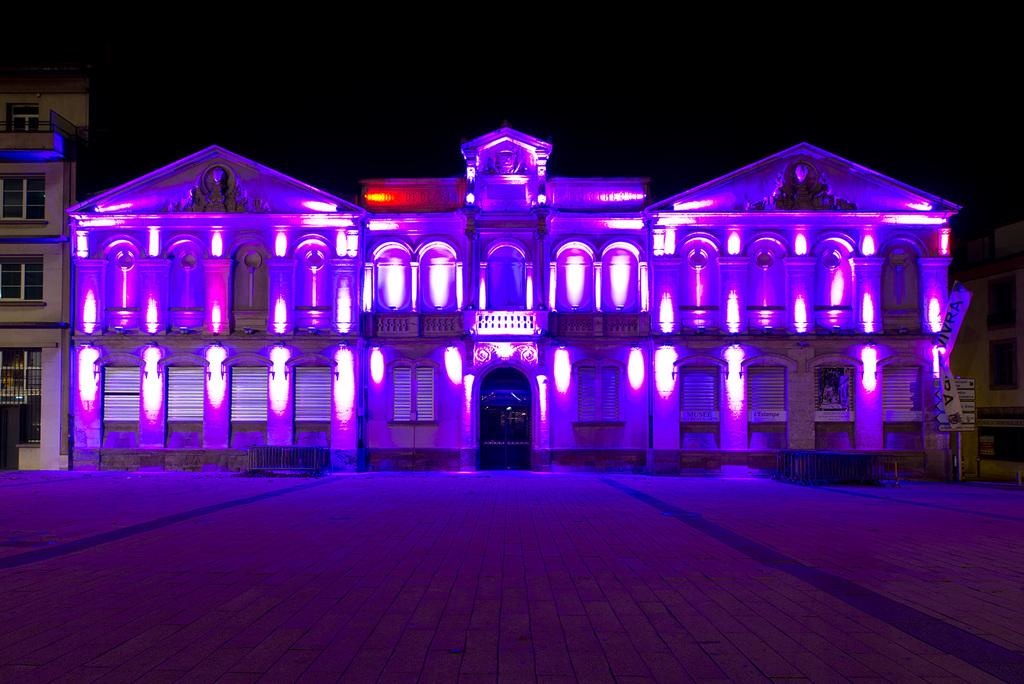What structures are present in the image? There are buildings in the image. What type of lighting can be seen in the image? There are purple color lights in the image. What can be seen in the background of the image? The sky is visible in the background of the image. What type of sign can be seen advertising wine in the image? There is no sign advertising wine present in the image. What type of teeth can be seen on the buildings in the image? Buildings do not have teeth, so this question cannot be answered. 